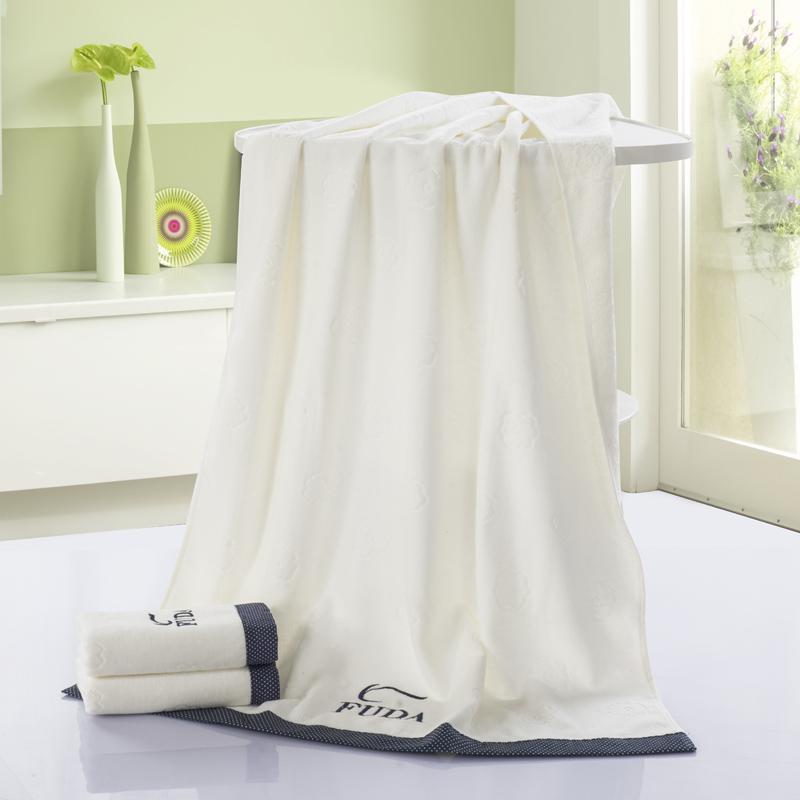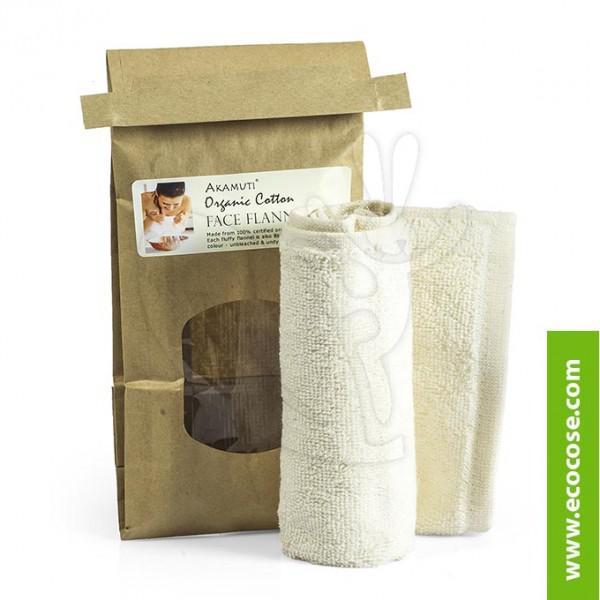The first image is the image on the left, the second image is the image on the right. Given the left and right images, does the statement "There is at least part of a toilet shown." hold true? Answer yes or no. No. 